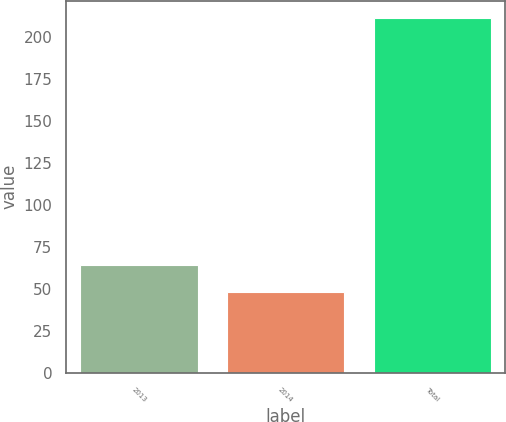Convert chart. <chart><loc_0><loc_0><loc_500><loc_500><bar_chart><fcel>2013<fcel>2014<fcel>Total<nl><fcel>64.3<fcel>48<fcel>211<nl></chart> 